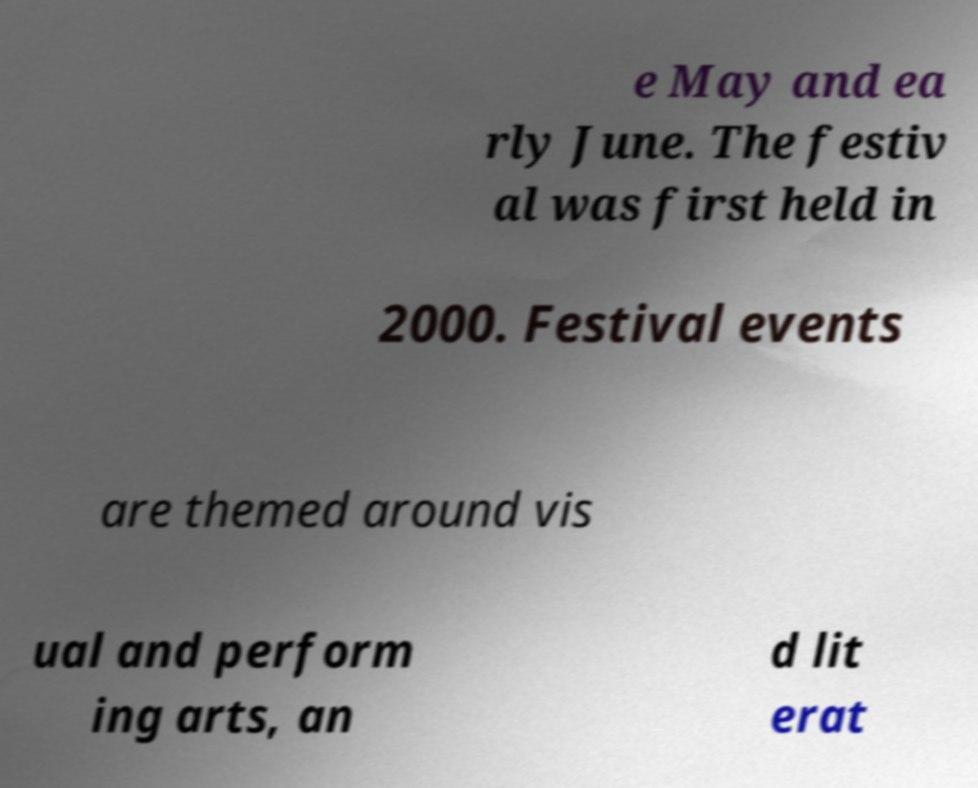Can you accurately transcribe the text from the provided image for me? e May and ea rly June. The festiv al was first held in 2000. Festival events are themed around vis ual and perform ing arts, an d lit erat 